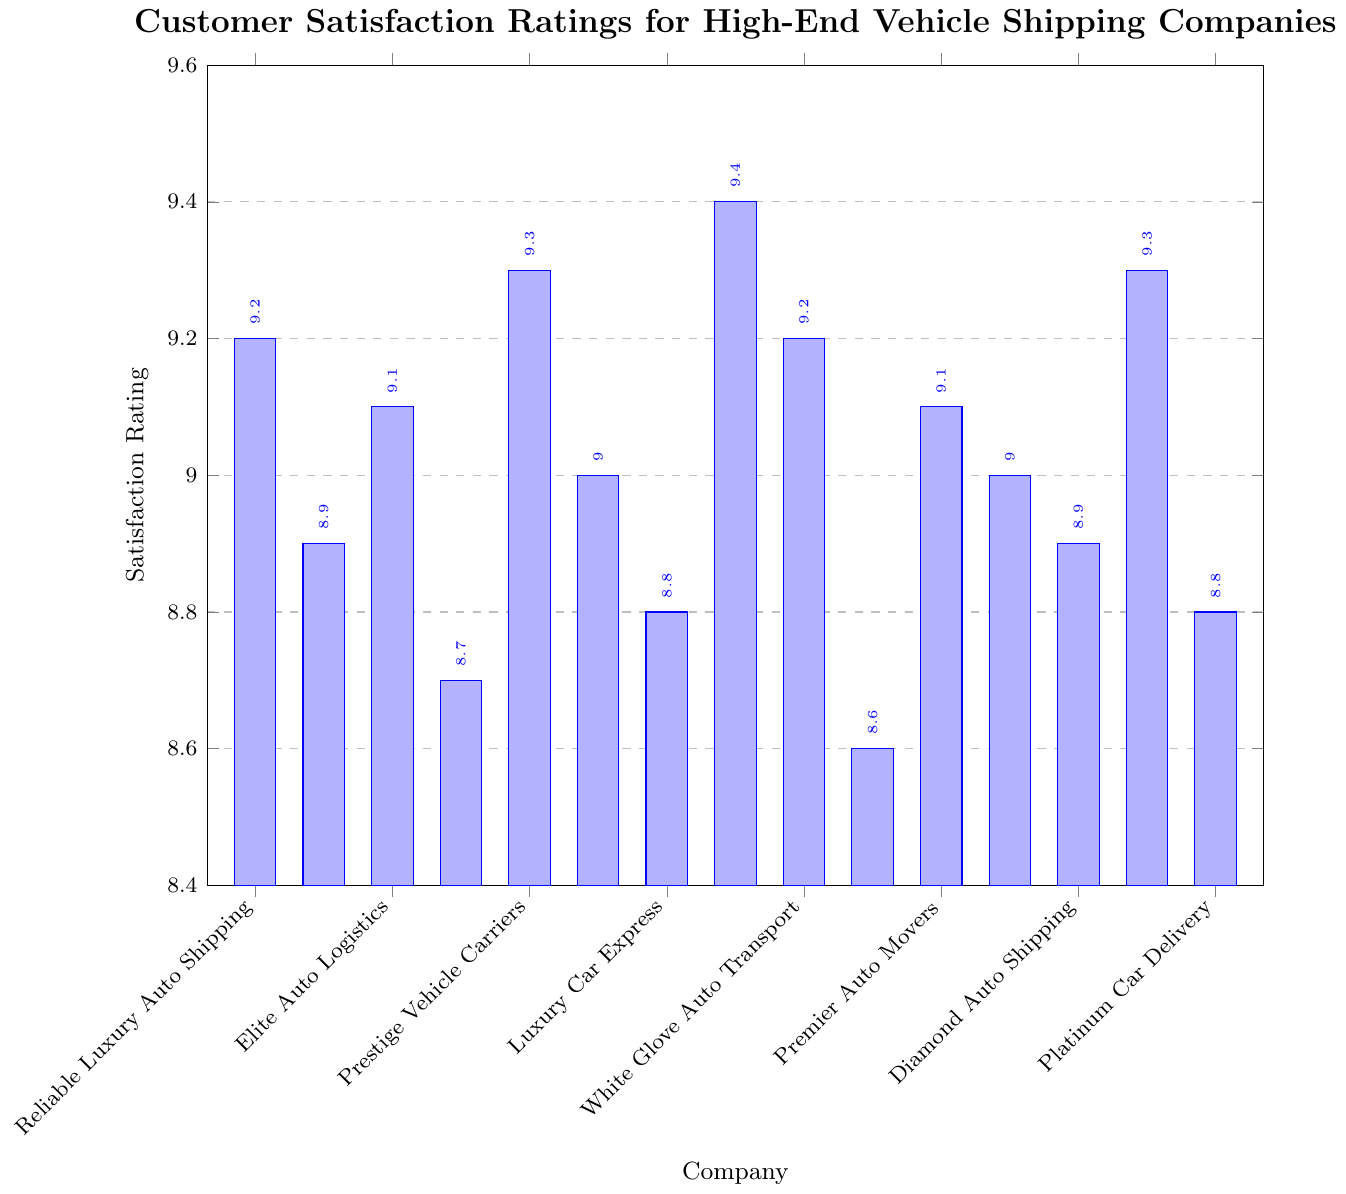Which company has the highest customer satisfaction rating? To find the highest customer satisfaction rating, look for the tallest bar in the chart. The tallest bar represents Diamond Auto Shipping with a rating of 9.4.
Answer: Diamond Auto Shipping Which two companies have an equal satisfaction rating of 9.2? Identify the bars that represent the satisfaction rating of 9.2. Exotic Car Transport and Platinum Car Delivery both have this rating.
Answer: Exotic Car Transport, Platinum Car Delivery What is the average satisfaction rating for all companies? Sum all the satisfaction ratings: 9.2 + 8.9 + 9.1 + 8.7 + 9.3 + 9.0 + 8.8 + 9.4 + 9.2 + 8.6 + 9.1 + 9.0 + 8.9 + 9.3 + 8.8 = 135.3. There are 15 companies, so divide the total by 15.
Answer: 9.02 Which company has the lowest customer satisfaction rating and what is it? Look for the shortest bar in the chart, which corresponds to Royal Ride Transportation with a rating of 8.6.
Answer: Royal Ride Transportation, 8.6 How many companies have a satisfaction rating greater than 9.0? Count the number of bars that exceed the 9.0 mark. The companies are Exotic Car Transport, Elite Auto Logistics, Luxury Car Express, Diamond Auto Shipping, Platinum Car Delivery, Golden Fleet Carriers, and Exclusive Auto Transport.
Answer: 7 Compare the satisfaction ratings of Reliable Luxury Auto Shipping and Prestige Vehicle Carriers. Which one is higher? Compare the heights of the bars for Reliable Luxury Auto Shipping (8.9) and Prestige Vehicle Carriers (8.7). Reliable Luxury Auto Shipping has a higher rating.
Answer: Reliable Luxury Auto Shipping Identify the company with a satisfaction rating of 9.0. Find the bar with a satisfaction rating of 9.0. There are two: White Glove Auto Transport and VIP Auto Logistics.
Answer: White Glove Auto Transport, VIP Auto Logistics What is the difference in satisfaction ratings between Luxury Car Express and Premier Auto Movers? Subtract the satisfaction rating of Premier Auto Movers (8.8) from Luxury Car Express (9.3).
Answer: 0.5 List the companies with a satisfaction rating below 9.0. Identify the bars with ratings below 9.0: Reliable Luxury Auto Shipping, Prestige Vehicle Carriers, Premier Auto Movers, Royal Ride Transportation, Signature Vehicle Shipping, Pinnacle Car Movers.
Answer: Reliable Luxury Auto Shipping, Prestige Vehicle Carriers, Premier Auto Movers, Royal Ride Transportation, Signature Vehicle Shipping, Pinnacle Car Movers What is the median satisfaction rating of all companies? Arrange the satisfaction ratings in ascending order: 8.6, 8.7, 8.8, 8.8, 8.9, 8.9, 9.0, 9.0, 9.1, 9.1, 9.2, 9.2, 9.3, 9.3, 9.4. With an odd number of 15 values, the median is the 8th value.
Answer: 9.0 